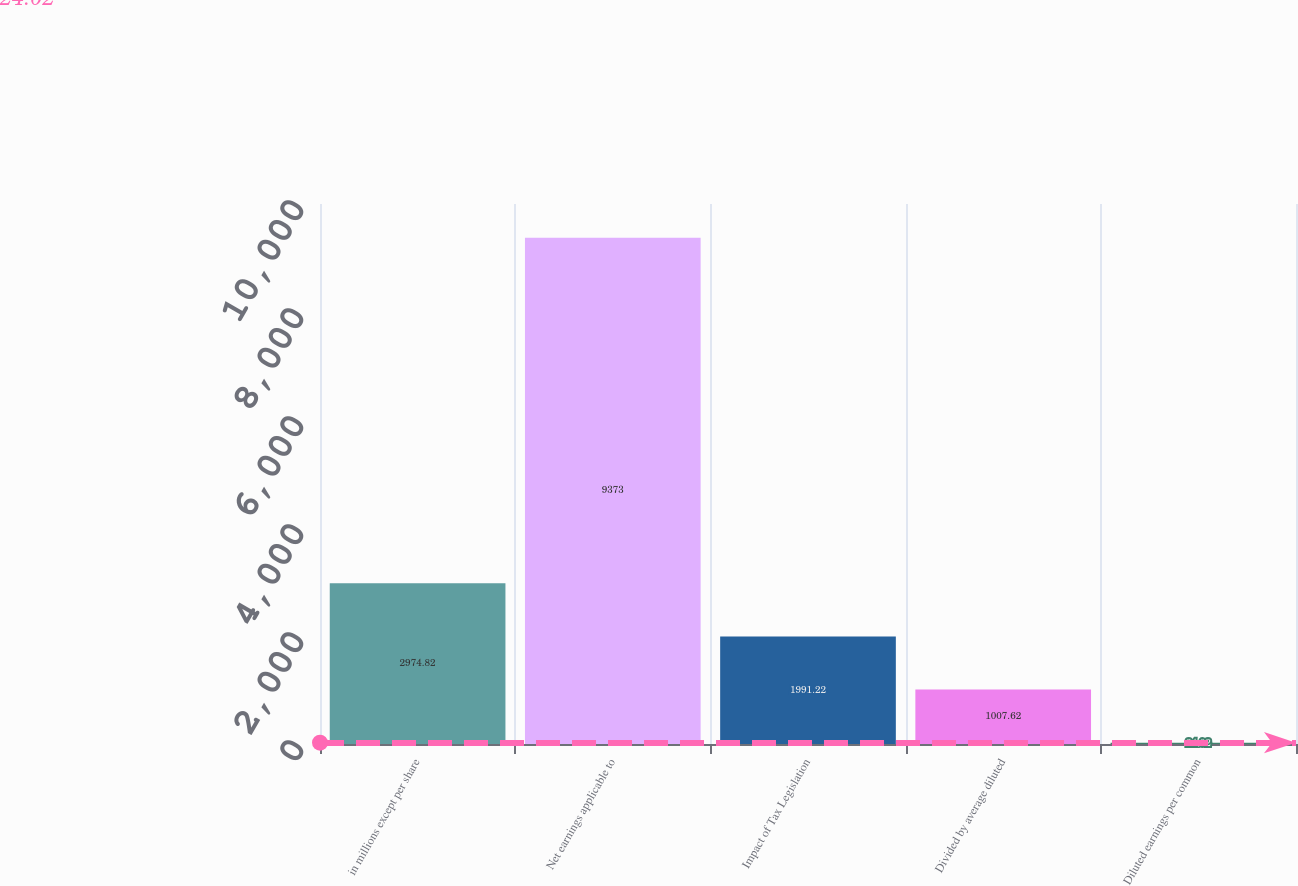Convert chart. <chart><loc_0><loc_0><loc_500><loc_500><bar_chart><fcel>in millions except per share<fcel>Net earnings applicable to<fcel>Impact of Tax Legislation<fcel>Divided by average diluted<fcel>Diluted earnings per common<nl><fcel>2974.82<fcel>9373<fcel>1991.22<fcel>1007.62<fcel>24.02<nl></chart> 